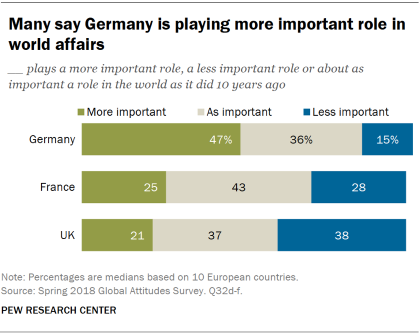Outline some significant characteristics in this image. A recent survey has revealed that 47% of people believe that Germany is playing a more significant role in world affairs today than it did 10 years ago. According to the survey, 68% of respondents believe that France is playing a more important role in world affairs compared to 10 years ago. 